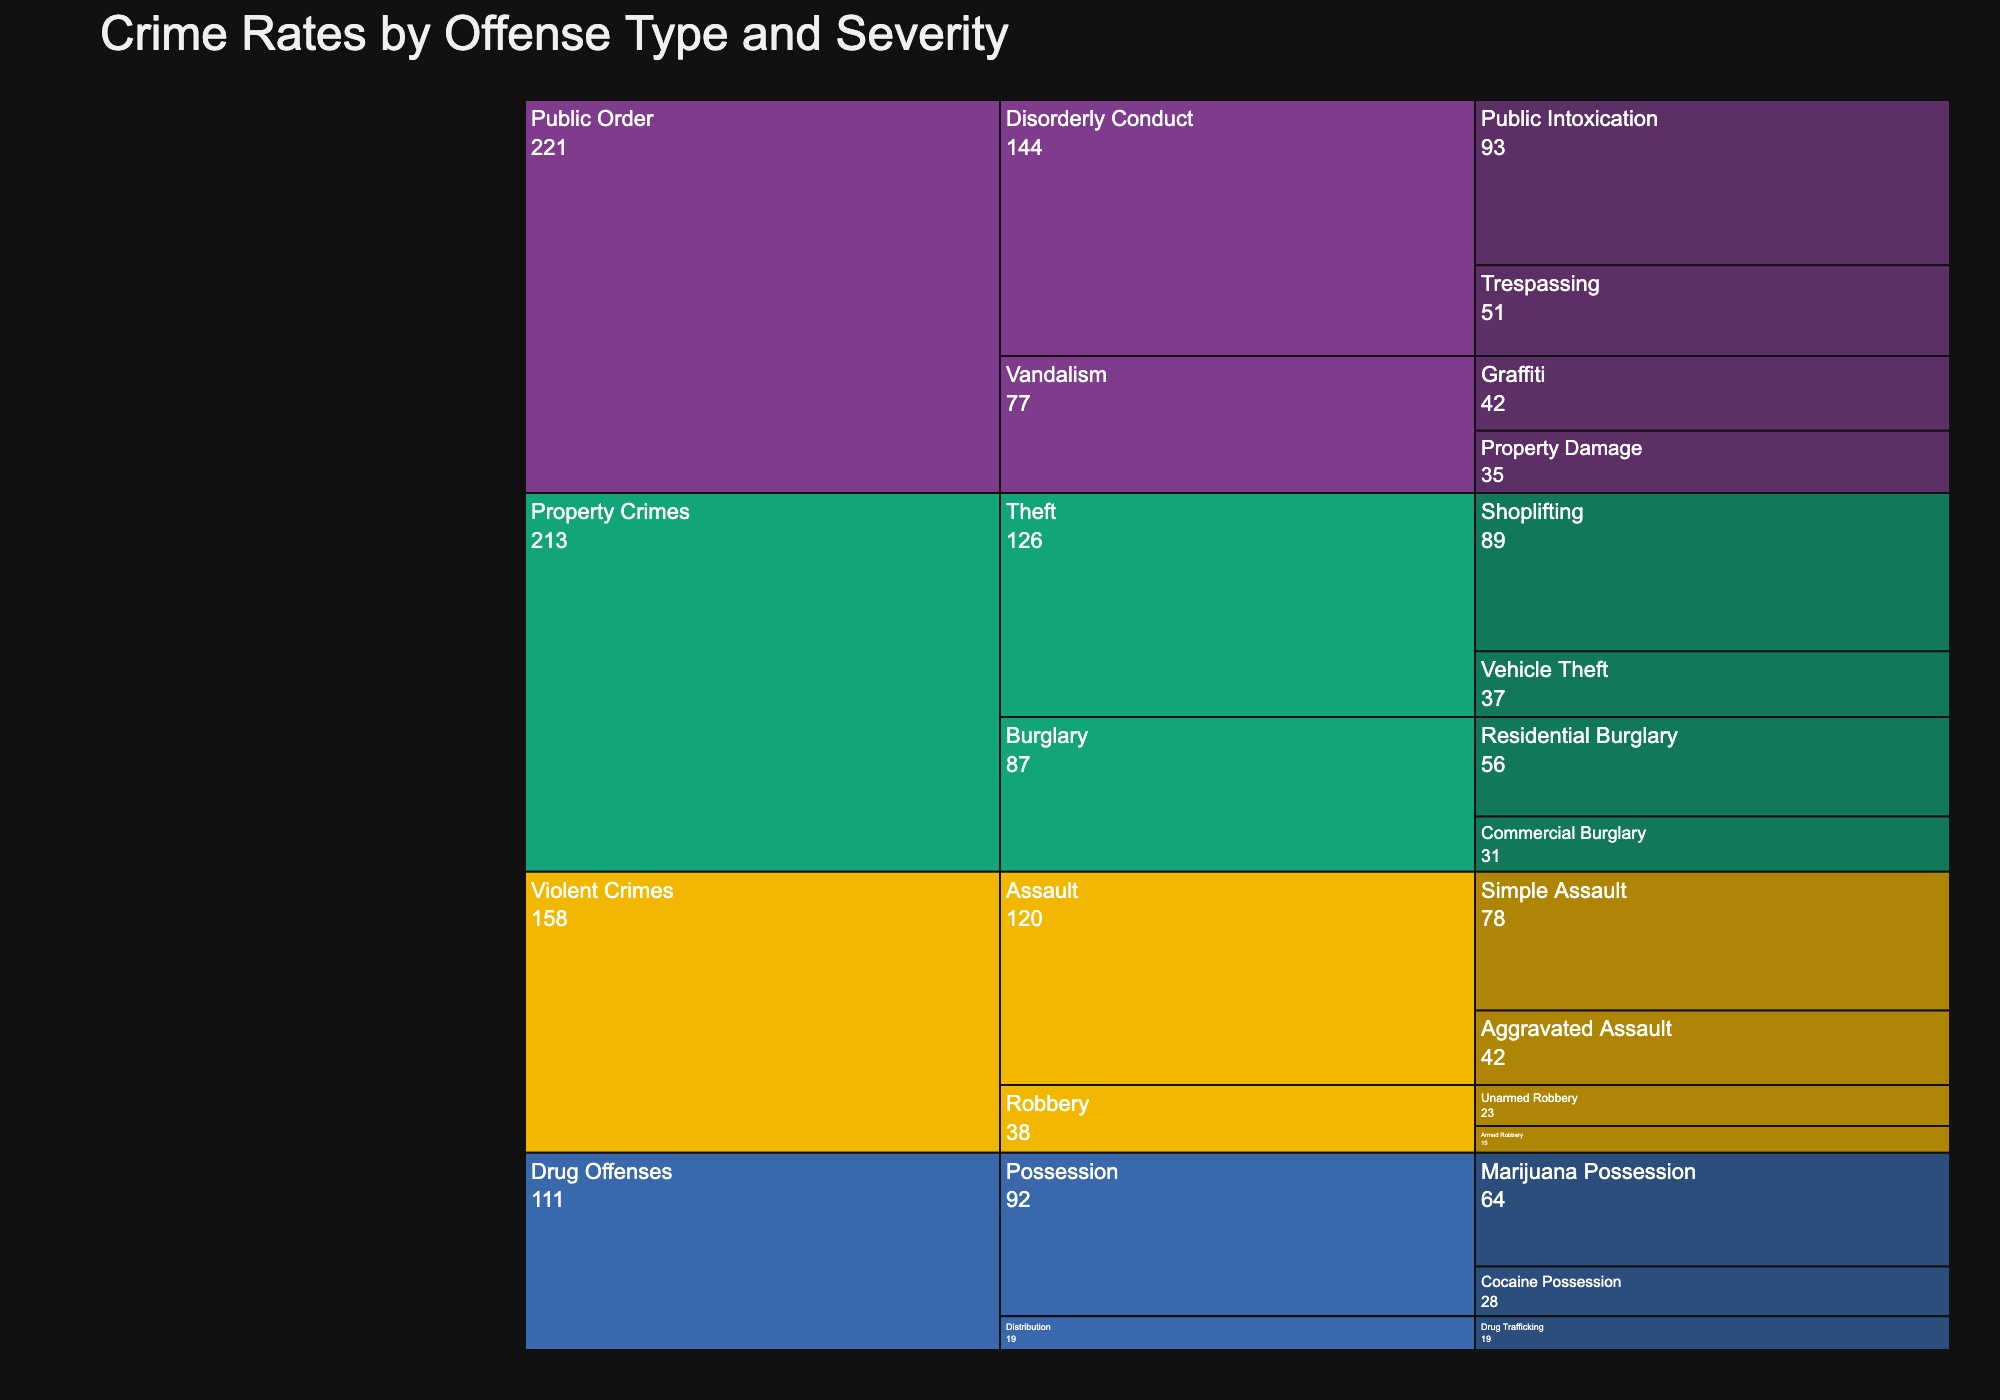What's the title of the chart? The title is generally placed at the top of the chart in larger and often bolder text.
Answer: Crime Rates by Offense Type and Severity How many types of offense fall under Property Crimes? Look under the Property Crimes category and count the number of unique types.
Answer: 2 How many total offenses are recorded for Public Order crimes? Sum up all the offenses under the Public Order category. The offenses are Public Intoxication (93), Trespassing (51), Graffiti (42), and Property Damage (35). So the total is 93 + 51 + 42 + 35.
Answer: 221 Which offense has the highest count in the entire chart? Identify the offense with the largest count number under all the categories and types.
Answer: Shoplifting How does the number of Armed Robbery offenses compare to Unarmed Robbery offenses? Look under the Robbery type in the Violent Crimes category, and compare the counts of Armed Robbery (15) and Unarmed Robbery (23).
Answer: Unarmed Robbery is higher What is the total count of offenses under Drug Offenses? Sum up all the offenses under the Drug Offenses category. The offenses are Marijuana Possession (64), Cocaine Possession (28), and Drug Trafficking (19). So the total is 64 + 28 + 19.
Answer: 111 In the Vandalism type under Public Order, which offense has a higher count? Look under the Vandalism type in the Public Order category and compare Graffiti (42) and Property Damage (35).
Answer: Graffiti Which category has the most offenses recorded? Sum up the offenses under each category and compare them. The categories to compare are Violent Crimes, Property Crimes, Drug Offenses, and Public Order.
Answer: Public Order What's the total count of Assault offenses? Sum the counts of both Aggravated Assault (42) and Simple Assault (78) under the Assault type in the Violent Crimes category.
Answer: 120 Which category has the least number of offenses recorded? Sum up the offenses under Violent Crimes, Property Crimes, Drug Offenses, and Public Order, then compare to find the smallest count.
Answer: Drug Offenses 